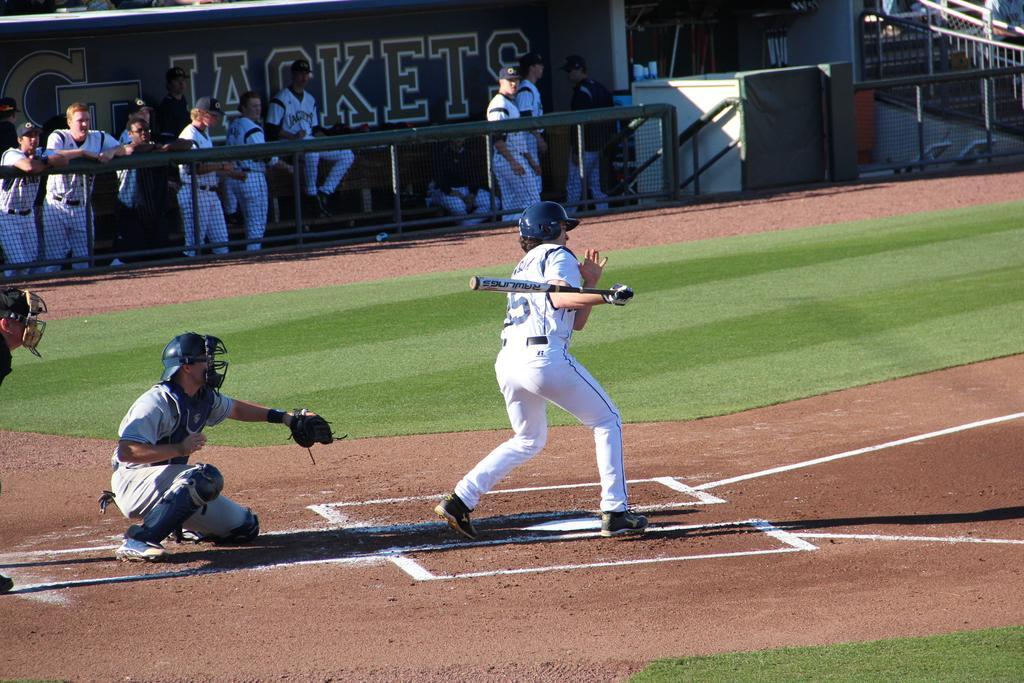Can you describe this image briefly? In this image we can see three persons who are playing baseball person wearing white color dress holding baseball stick in his hands and in the background of the image there are some persons standing and some are leaning to the fencing, on the right side of the image there are some stairs. 